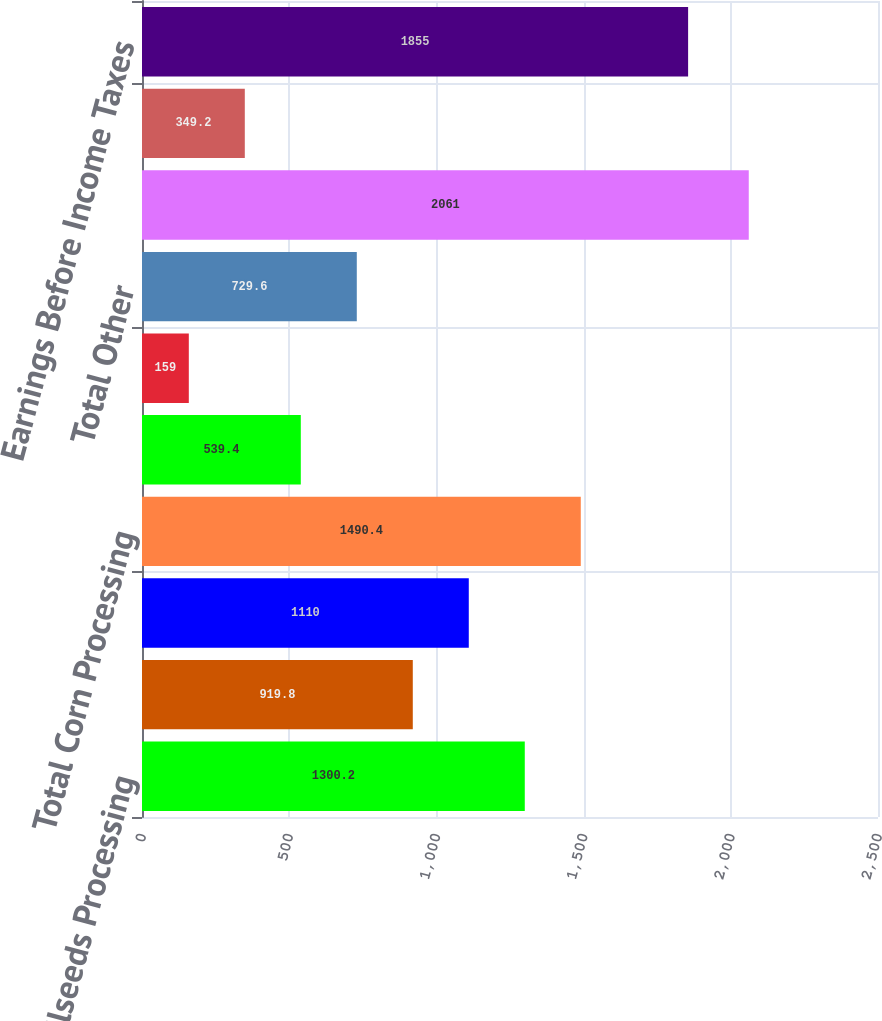Convert chart. <chart><loc_0><loc_0><loc_500><loc_500><bar_chart><fcel>Oilseeds Processing<fcel>Sweeteners and Starches<fcel>Bioproducts<fcel>Total Corn Processing<fcel>Agricultural Services<fcel>Food Feed and Industrial<fcel>Total Other<fcel>Total Segment Operating Profit<fcel>Corporate<fcel>Earnings Before Income Taxes<nl><fcel>1300.2<fcel>919.8<fcel>1110<fcel>1490.4<fcel>539.4<fcel>159<fcel>729.6<fcel>2061<fcel>349.2<fcel>1855<nl></chart> 